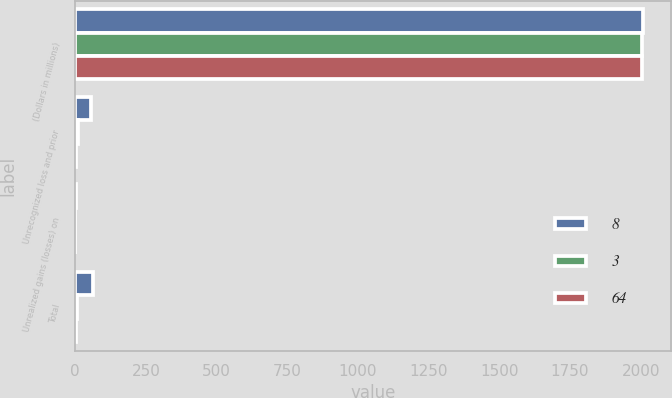Convert chart. <chart><loc_0><loc_0><loc_500><loc_500><stacked_bar_chart><ecel><fcel>(Dollars in millions)<fcel>Unrecognized loss and prior<fcel>Unrealized gains (losses) on<fcel>Total<nl><fcel>8<fcel>2007<fcel>56<fcel>3<fcel>64<nl><fcel>3<fcel>2006<fcel>9<fcel>1<fcel>8<nl><fcel>64<fcel>2005<fcel>4<fcel>1<fcel>3<nl></chart> 